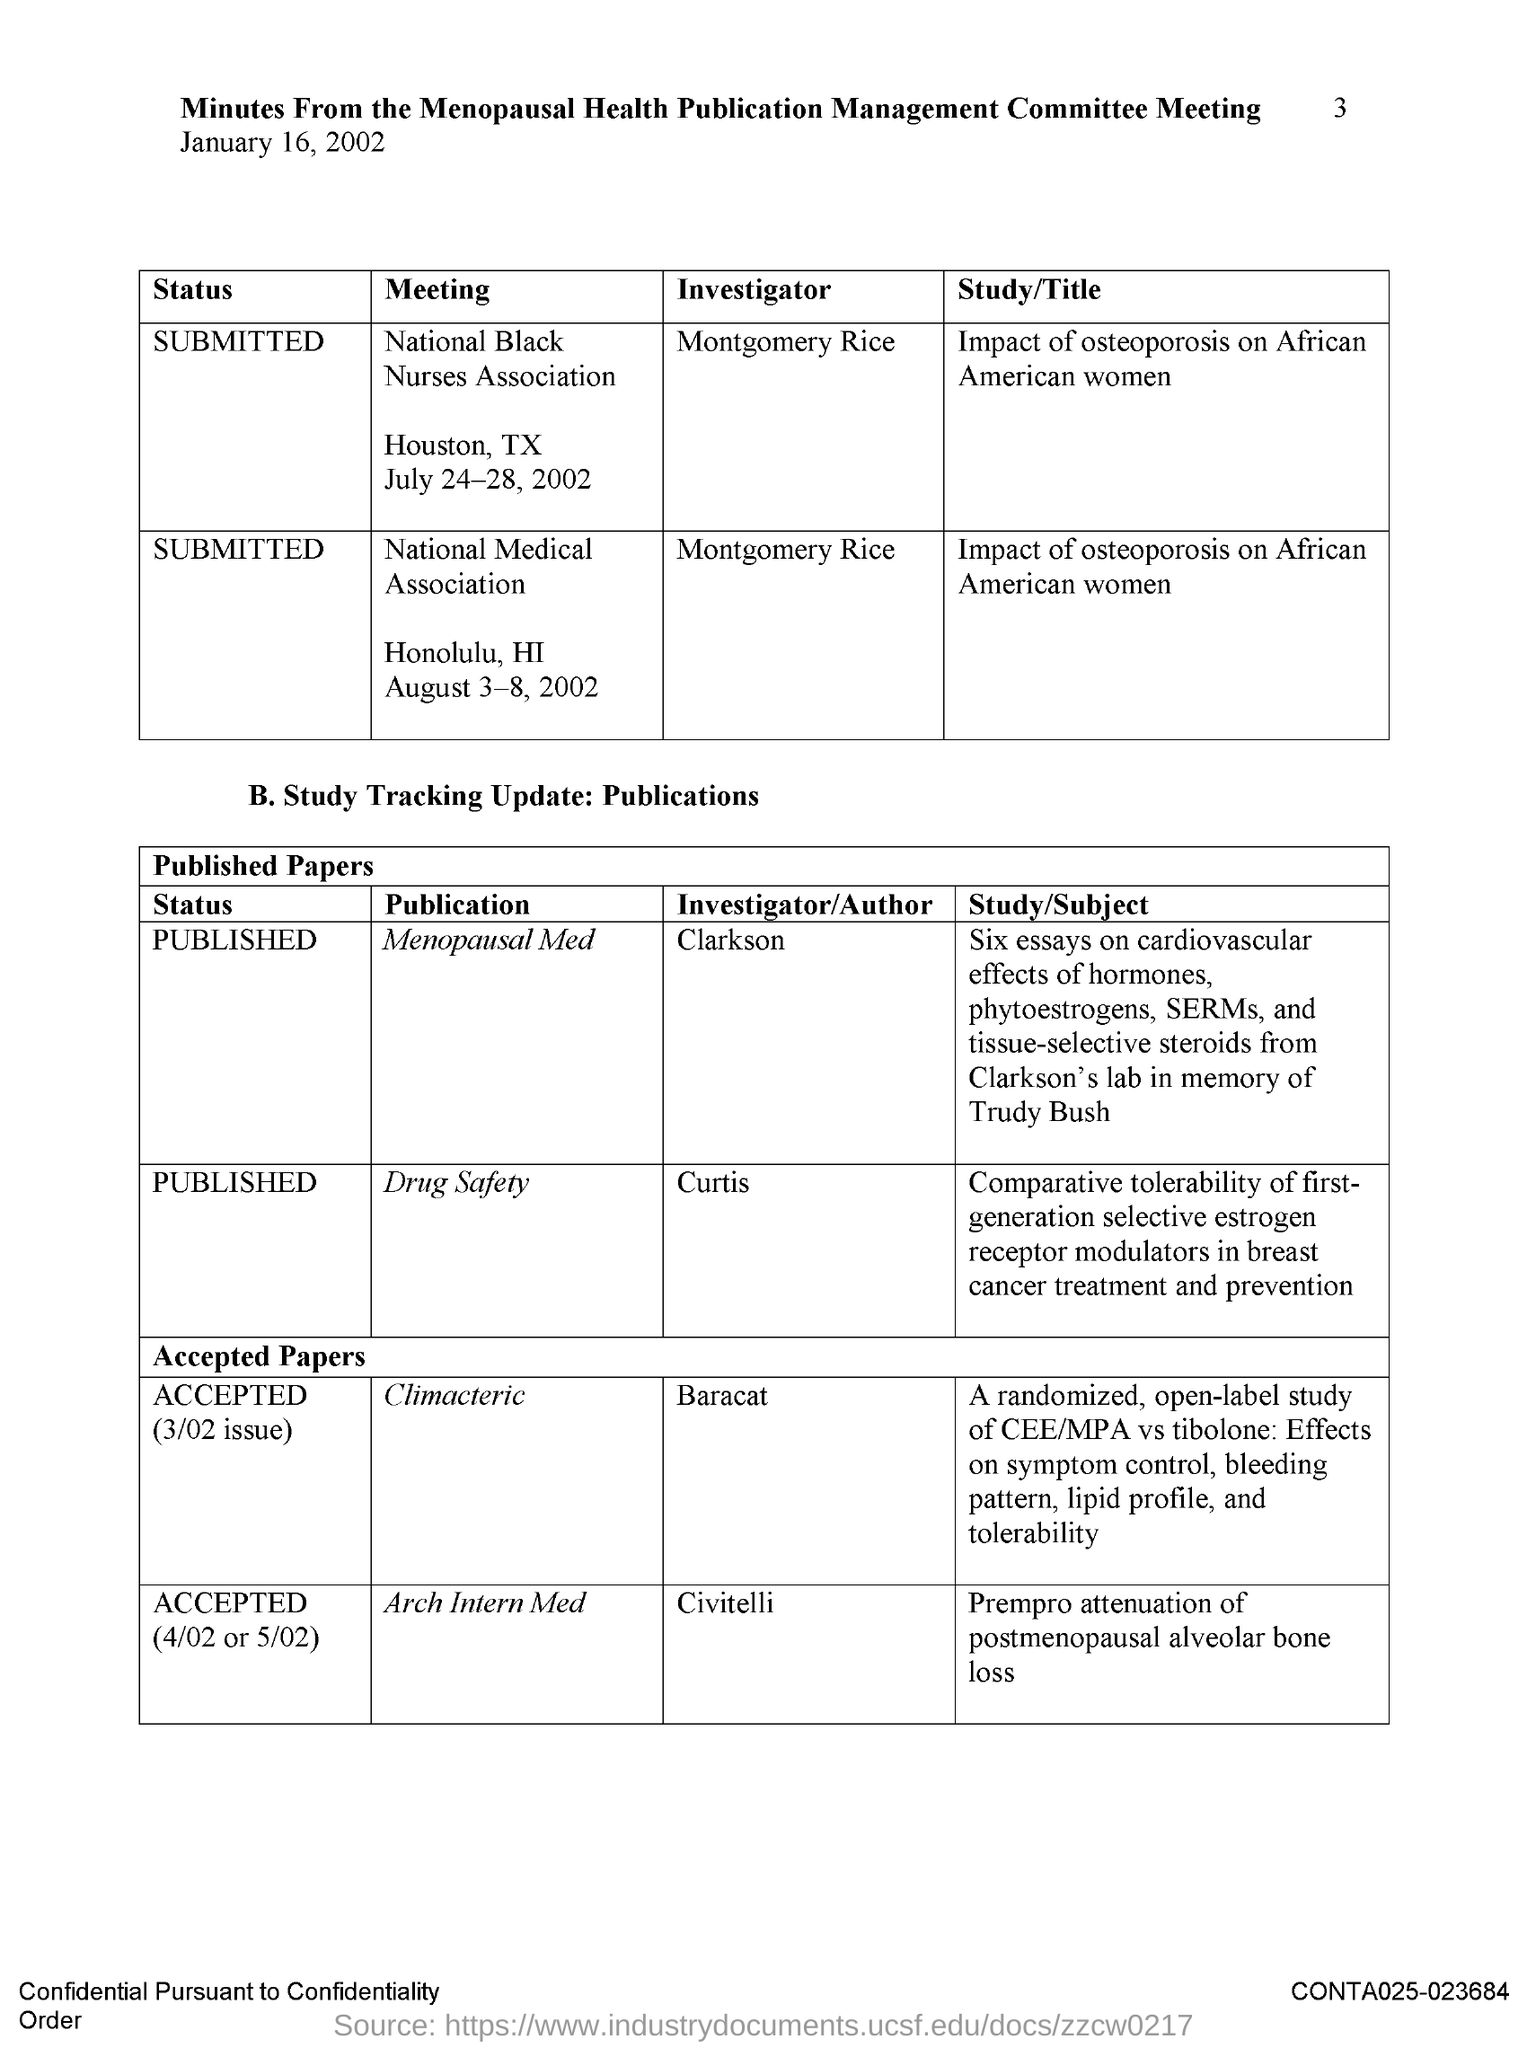Who is the Investigator for the publication Drug Safety?
Your answer should be very brief. Curtis. Who is the Investigator for the publication Climacteric?
Your response must be concise. Baracat. 